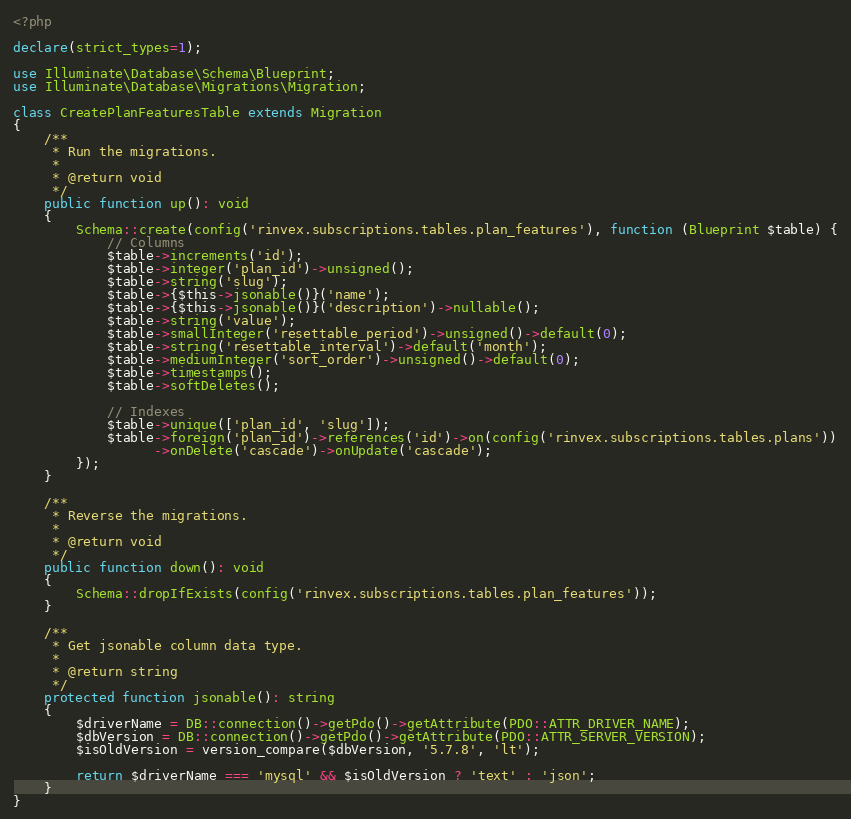Convert code to text. <code><loc_0><loc_0><loc_500><loc_500><_PHP_><?php

declare(strict_types=1);

use Illuminate\Database\Schema\Blueprint;
use Illuminate\Database\Migrations\Migration;

class CreatePlanFeaturesTable extends Migration
{
    /**
     * Run the migrations.
     *
     * @return void
     */
    public function up(): void
    {
        Schema::create(config('rinvex.subscriptions.tables.plan_features'), function (Blueprint $table) {
            // Columns
            $table->increments('id');
            $table->integer('plan_id')->unsigned();
            $table->string('slug');
            $table->{$this->jsonable()}('name');
            $table->{$this->jsonable()}('description')->nullable();
            $table->string('value');
            $table->smallInteger('resettable_period')->unsigned()->default(0);
            $table->string('resettable_interval')->default('month');
            $table->mediumInteger('sort_order')->unsigned()->default(0);
            $table->timestamps();
            $table->softDeletes();

            // Indexes
            $table->unique(['plan_id', 'slug']);
            $table->foreign('plan_id')->references('id')->on(config('rinvex.subscriptions.tables.plans'))
                  ->onDelete('cascade')->onUpdate('cascade');
        });
    }

    /**
     * Reverse the migrations.
     *
     * @return void
     */
    public function down(): void
    {
        Schema::dropIfExists(config('rinvex.subscriptions.tables.plan_features'));
    }

    /**
     * Get jsonable column data type.
     *
     * @return string
     */
    protected function jsonable(): string
    {
        $driverName = DB::connection()->getPdo()->getAttribute(PDO::ATTR_DRIVER_NAME);
        $dbVersion = DB::connection()->getPdo()->getAttribute(PDO::ATTR_SERVER_VERSION);
        $isOldVersion = version_compare($dbVersion, '5.7.8', 'lt');

        return $driverName === 'mysql' && $isOldVersion ? 'text' : 'json';
    }
}
</code> 